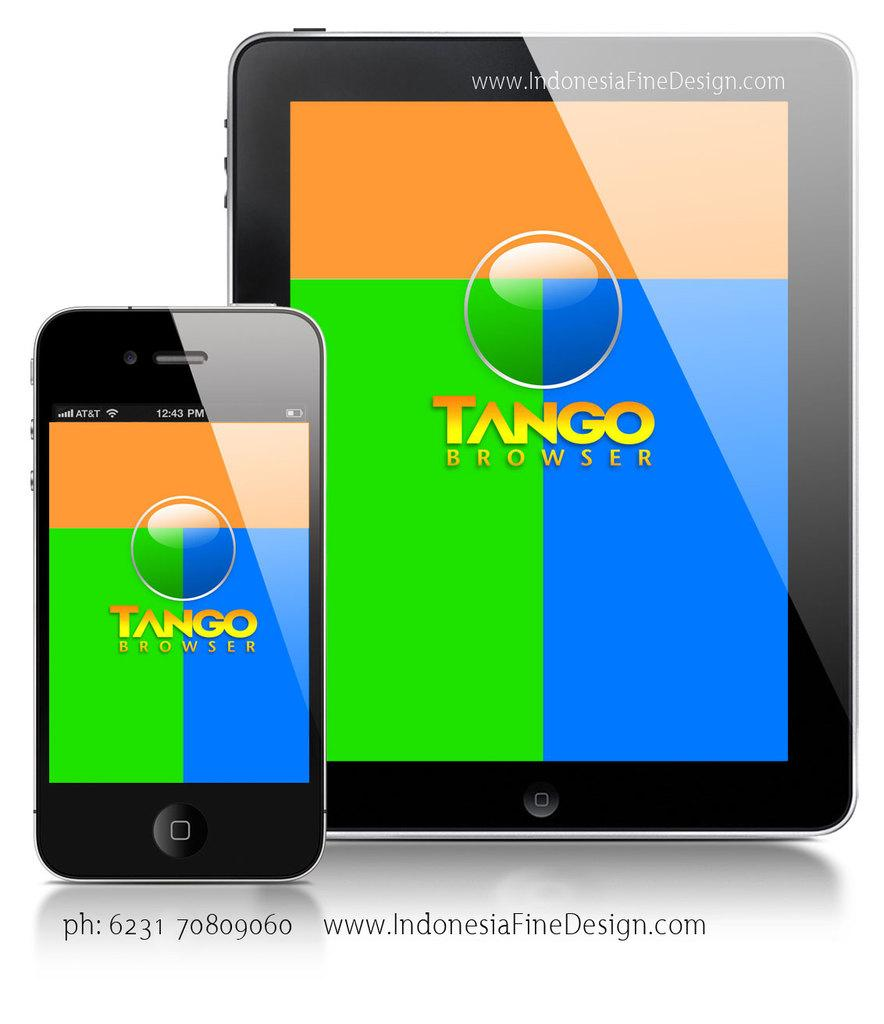<image>
Relay a brief, clear account of the picture shown. an iphone next to an ipad that both say 'tango browser' 